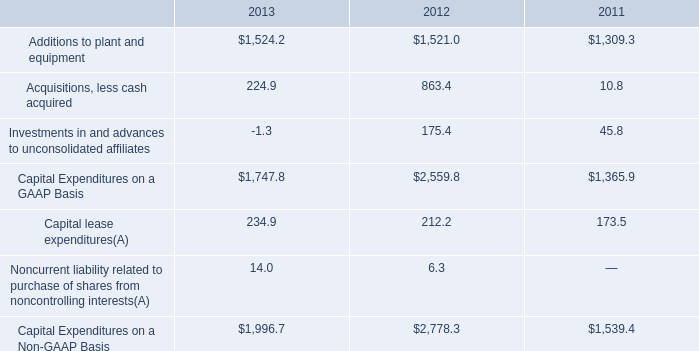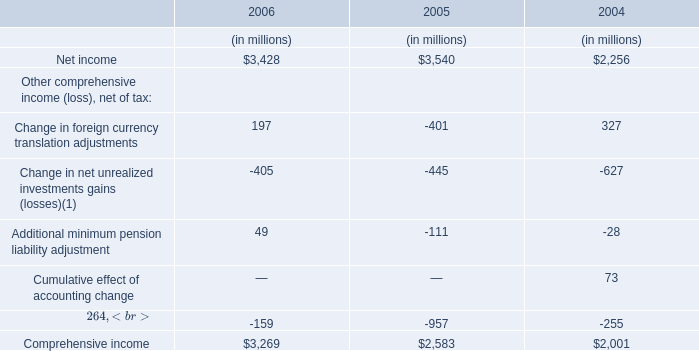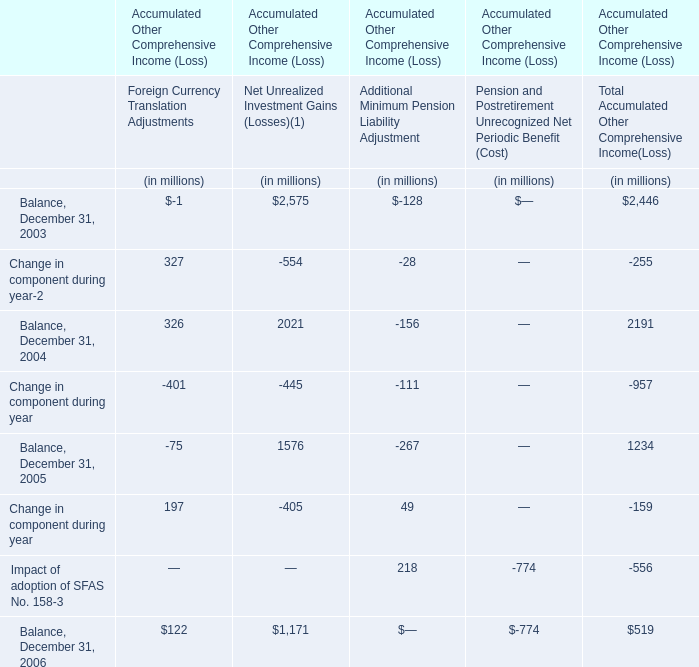What is the total value of the Net income in 2005, the Comprehensive income in 2005, the Net income in 2006 and the Comprehensive income in 2006? (in million) 
Computations: (((3540 + 2583) + 3428) + 3269)
Answer: 12820.0. 